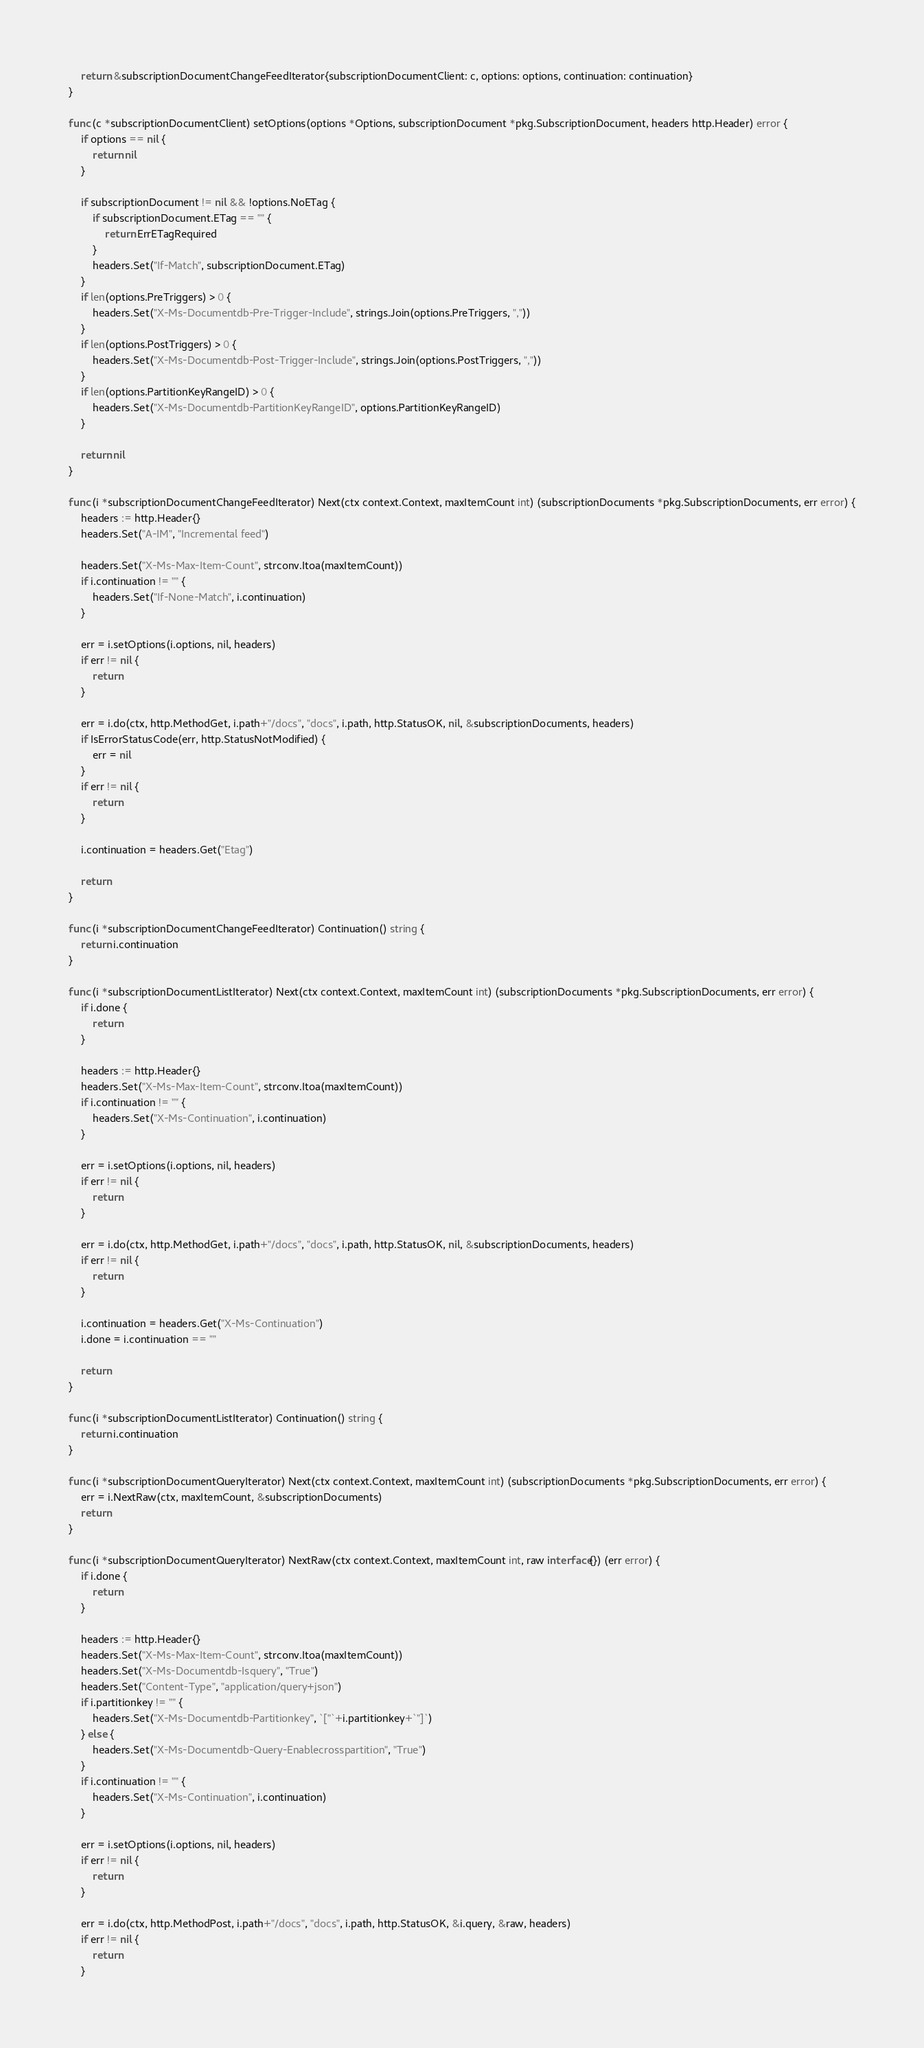Convert code to text. <code><loc_0><loc_0><loc_500><loc_500><_Go_>	return &subscriptionDocumentChangeFeedIterator{subscriptionDocumentClient: c, options: options, continuation: continuation}
}

func (c *subscriptionDocumentClient) setOptions(options *Options, subscriptionDocument *pkg.SubscriptionDocument, headers http.Header) error {
	if options == nil {
		return nil
	}

	if subscriptionDocument != nil && !options.NoETag {
		if subscriptionDocument.ETag == "" {
			return ErrETagRequired
		}
		headers.Set("If-Match", subscriptionDocument.ETag)
	}
	if len(options.PreTriggers) > 0 {
		headers.Set("X-Ms-Documentdb-Pre-Trigger-Include", strings.Join(options.PreTriggers, ","))
	}
	if len(options.PostTriggers) > 0 {
		headers.Set("X-Ms-Documentdb-Post-Trigger-Include", strings.Join(options.PostTriggers, ","))
	}
	if len(options.PartitionKeyRangeID) > 0 {
		headers.Set("X-Ms-Documentdb-PartitionKeyRangeID", options.PartitionKeyRangeID)
	}

	return nil
}

func (i *subscriptionDocumentChangeFeedIterator) Next(ctx context.Context, maxItemCount int) (subscriptionDocuments *pkg.SubscriptionDocuments, err error) {
	headers := http.Header{}
	headers.Set("A-IM", "Incremental feed")

	headers.Set("X-Ms-Max-Item-Count", strconv.Itoa(maxItemCount))
	if i.continuation != "" {
		headers.Set("If-None-Match", i.continuation)
	}

	err = i.setOptions(i.options, nil, headers)
	if err != nil {
		return
	}

	err = i.do(ctx, http.MethodGet, i.path+"/docs", "docs", i.path, http.StatusOK, nil, &subscriptionDocuments, headers)
	if IsErrorStatusCode(err, http.StatusNotModified) {
		err = nil
	}
	if err != nil {
		return
	}

	i.continuation = headers.Get("Etag")

	return
}

func (i *subscriptionDocumentChangeFeedIterator) Continuation() string {
	return i.continuation
}

func (i *subscriptionDocumentListIterator) Next(ctx context.Context, maxItemCount int) (subscriptionDocuments *pkg.SubscriptionDocuments, err error) {
	if i.done {
		return
	}

	headers := http.Header{}
	headers.Set("X-Ms-Max-Item-Count", strconv.Itoa(maxItemCount))
	if i.continuation != "" {
		headers.Set("X-Ms-Continuation", i.continuation)
	}

	err = i.setOptions(i.options, nil, headers)
	if err != nil {
		return
	}

	err = i.do(ctx, http.MethodGet, i.path+"/docs", "docs", i.path, http.StatusOK, nil, &subscriptionDocuments, headers)
	if err != nil {
		return
	}

	i.continuation = headers.Get("X-Ms-Continuation")
	i.done = i.continuation == ""

	return
}

func (i *subscriptionDocumentListIterator) Continuation() string {
	return i.continuation
}

func (i *subscriptionDocumentQueryIterator) Next(ctx context.Context, maxItemCount int) (subscriptionDocuments *pkg.SubscriptionDocuments, err error) {
	err = i.NextRaw(ctx, maxItemCount, &subscriptionDocuments)
	return
}

func (i *subscriptionDocumentQueryIterator) NextRaw(ctx context.Context, maxItemCount int, raw interface{}) (err error) {
	if i.done {
		return
	}

	headers := http.Header{}
	headers.Set("X-Ms-Max-Item-Count", strconv.Itoa(maxItemCount))
	headers.Set("X-Ms-Documentdb-Isquery", "True")
	headers.Set("Content-Type", "application/query+json")
	if i.partitionkey != "" {
		headers.Set("X-Ms-Documentdb-Partitionkey", `["`+i.partitionkey+`"]`)
	} else {
		headers.Set("X-Ms-Documentdb-Query-Enablecrosspartition", "True")
	}
	if i.continuation != "" {
		headers.Set("X-Ms-Continuation", i.continuation)
	}

	err = i.setOptions(i.options, nil, headers)
	if err != nil {
		return
	}

	err = i.do(ctx, http.MethodPost, i.path+"/docs", "docs", i.path, http.StatusOK, &i.query, &raw, headers)
	if err != nil {
		return
	}
</code> 